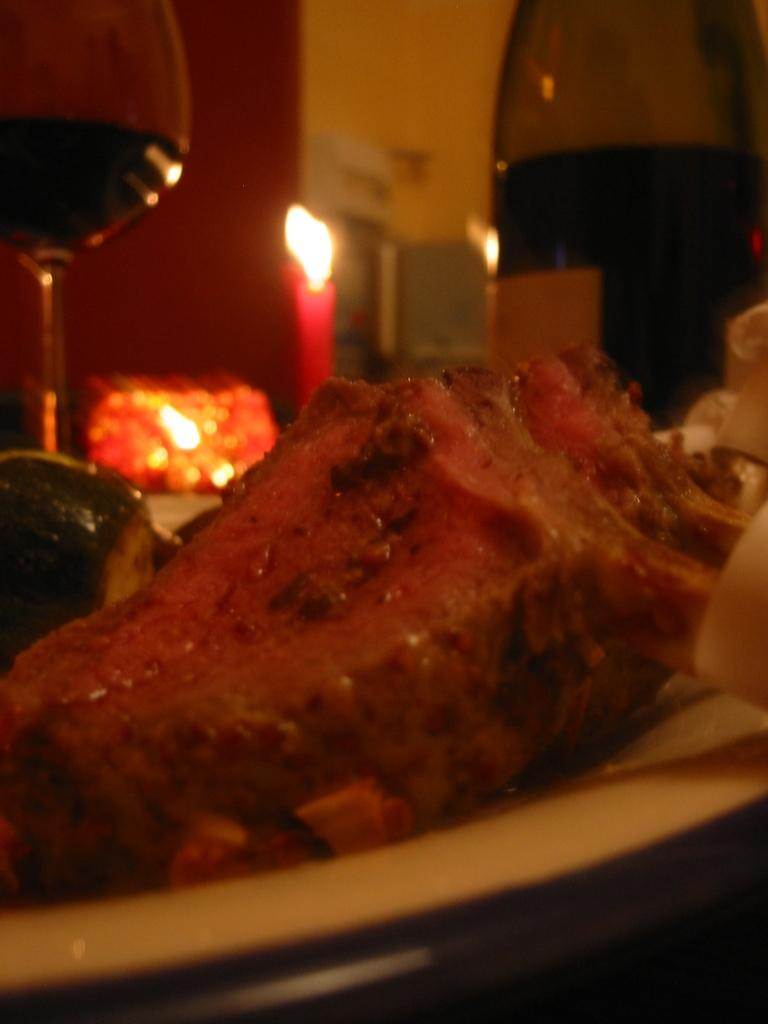What is on the plate in the image? There is food in a plate in the image. What type of glassware is present in the image? There is a wine glass in the image. What is the other alcoholic beverage container in the image? There is a wine bottle in the image. What additional item can be seen in the image? There is a candle in the image. How would you describe the background of the image? The background of the image is blurred. How many rabbits can be seen in the wilderness in the image? There are no rabbits or wilderness present in the image. What is the candle being used for in the image? The purpose of the candle cannot be determined from the image alone, as it may be for decoration, ambiance, or a practical purpose. 